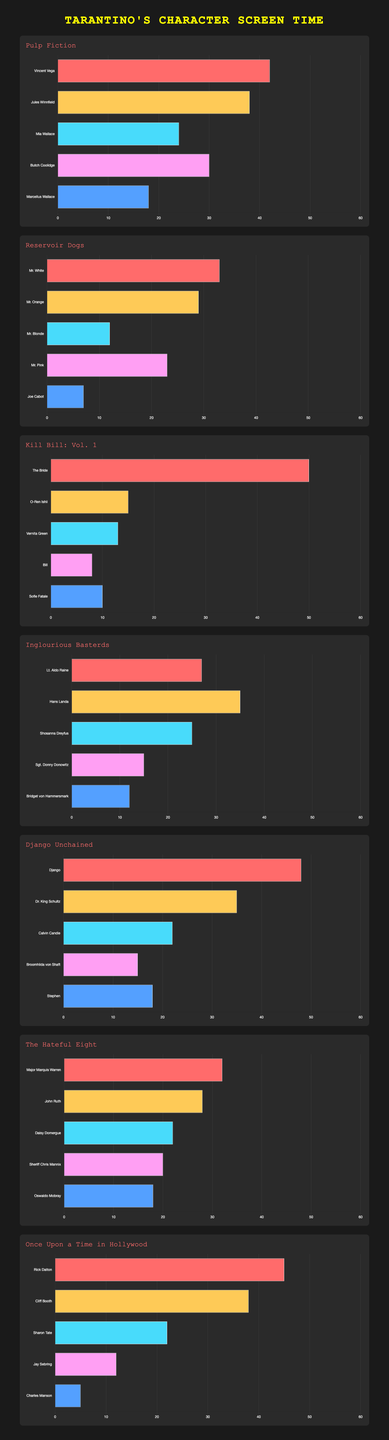What's the sum of screen time for Vincent Vega and Jules Winnfield in "Pulp Fiction"? Vincent Vega has 42 minutes of screen time, and Jules Winnfield has 38 minutes of screen time. Adding these together gives 42 + 38 = 80 minutes.
Answer: 80 minutes Which character has more screen time, Mr. White from "Reservoir Dogs" or Lt. Aldo Raine from "Inglourious Basterds"? Mr. White has 33 minutes of screen time, while Lt. Aldo Raine has 27. Comparing these two, 33 is greater than 27.
Answer: Mr. White Who has the least screen time in "Once Upon a Time in Hollywood"? The character with the least screen time is Charles Manson with 5 minutes.
Answer: Charles Manson What's the average screen time for the top three characters in "Kill Bill: Vol. 1"? The screen times for the top three characters are The Bride (50), O-Ren Ishii (15), and Vernita Green (13). Adding these together gives 50 + 15 + 13 = 78. Dividing by 3 gives 78 / 3 ≈ 26 minutes.
Answer: ~26 minutes In "Django Unchained", which character has the second longest screen time? The longest screen time is Django with 48 minutes, and the second longest is Dr. King Schultz with 35 minutes.
Answer: Dr. King Schultz What is the total screen time for all characters in "The Hateful Eight"? Adding all the screen times: Major Marquis Warren (32), John Ruth (28), Daisy Domergue (22), Sheriff Chris Mannix (20), and Oswaldo Mobray (18), we get 32 + 28 + 22 + 20 + 18 = 120 minutes.
Answer: 120 minutes Compare the screen time for The Bride in "Kill Bill: Vol. 1" and Django in "Django Unchained". Who has more, and by how much? The Bride has 50 minutes and Django has 48 minutes. The Bride has 50 - 48 = 2 minutes more.
Answer: The Bride by 2 minutes Which two characters have equal screen time in "Reservoir Dogs" and "Inglourious Basterds"? In "Reservoir Dogs", Mr. Orange has a screen time of 29 minutes. In "Inglourious Basterds", no character has exactly 29 minutes of screen time, so no characters have equal screen time.
Answer: No characters If we combine the screen time of Vincent Vega and Butch Coolidge from "Pulp Fiction," will it exceed the screen time of The Bride from "Kill Bill: Vol. 1"? Vincent Vega has 42 minutes and Butch Coolidge has 30 minutes. Combined, they have 42 + 30 = 72 minutes. The Bride has 50 minutes, so 72 is greater than 50.
Answer: Yes 